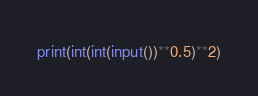Convert code to text. <code><loc_0><loc_0><loc_500><loc_500><_Python_>print(int(int(input())**0.5)**2)</code> 